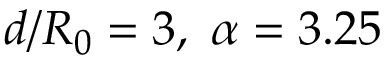Convert formula to latex. <formula><loc_0><loc_0><loc_500><loc_500>d / R _ { 0 } = 3 , \ \alpha = 3 . 2 5</formula> 